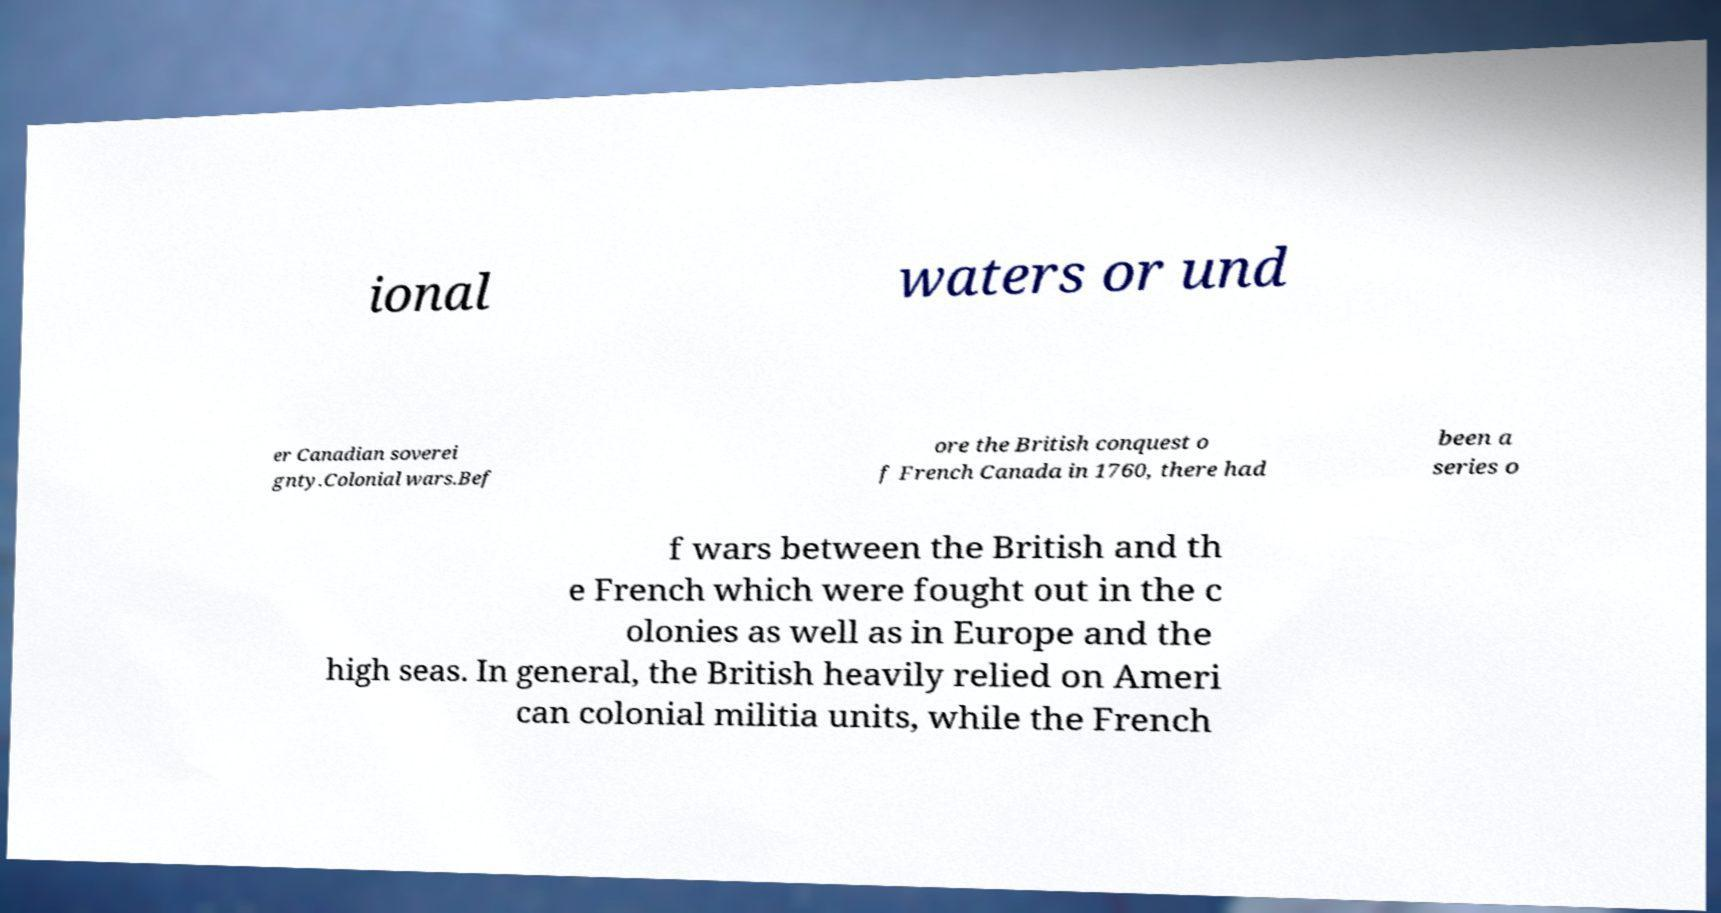Can you read and provide the text displayed in the image?This photo seems to have some interesting text. Can you extract and type it out for me? ional waters or und er Canadian soverei gnty.Colonial wars.Bef ore the British conquest o f French Canada in 1760, there had been a series o f wars between the British and th e French which were fought out in the c olonies as well as in Europe and the high seas. In general, the British heavily relied on Ameri can colonial militia units, while the French 